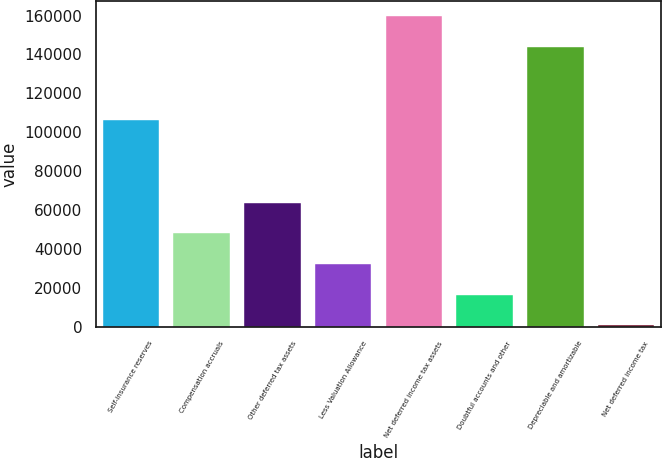Convert chart. <chart><loc_0><loc_0><loc_500><loc_500><bar_chart><fcel>Self-insurance reserves<fcel>Compensation accruals<fcel>Other deferred tax assets<fcel>Less Valuation Allowance<fcel>Net deferred income tax assets<fcel>Doubtful accounts and other<fcel>Depreciable and amortizable<fcel>Net deferred income tax<nl><fcel>106521<fcel>48121.5<fcel>63837<fcel>32406<fcel>159516<fcel>16690.5<fcel>143800<fcel>975<nl></chart> 